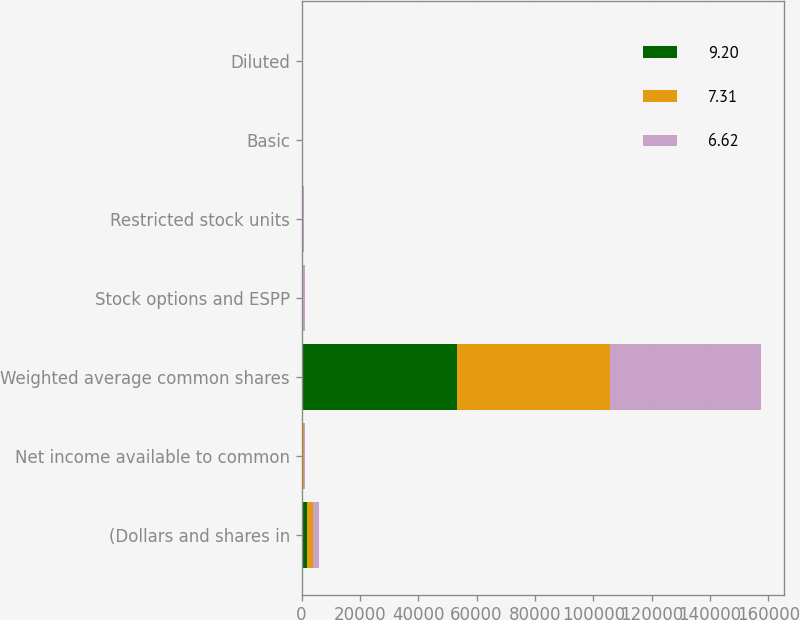Convert chart. <chart><loc_0><loc_0><loc_500><loc_500><stacked_bar_chart><ecel><fcel>(Dollars and shares in<fcel>Net income available to common<fcel>Weighted average common shares<fcel>Stock options and ESPP<fcel>Restricted stock units<fcel>Basic<fcel>Diluted<nl><fcel>9.2<fcel>2017<fcel>385<fcel>53306<fcel>385<fcel>333<fcel>9.33<fcel>9.2<nl><fcel>7.31<fcel>2016<fcel>385<fcel>52349<fcel>254<fcel>180<fcel>7.37<fcel>7.31<nl><fcel>6.62<fcel>2015<fcel>385<fcel>51916<fcel>387<fcel>211<fcel>6.7<fcel>6.62<nl></chart> 